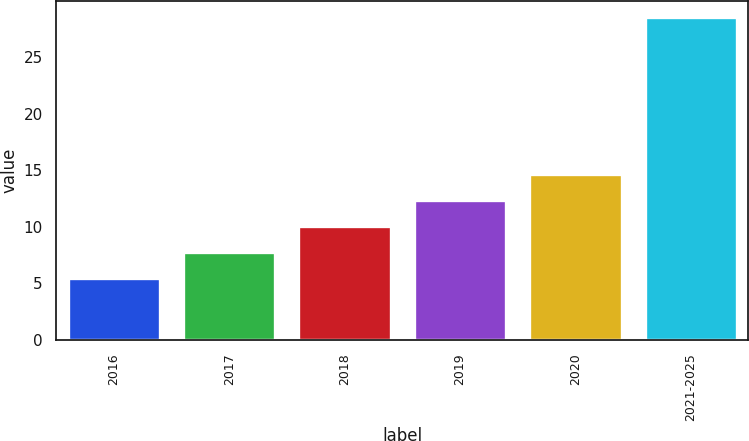Convert chart. <chart><loc_0><loc_0><loc_500><loc_500><bar_chart><fcel>2016<fcel>2017<fcel>2018<fcel>2019<fcel>2020<fcel>2021-2025<nl><fcel>5.5<fcel>7.8<fcel>10.1<fcel>12.4<fcel>14.7<fcel>28.5<nl></chart> 